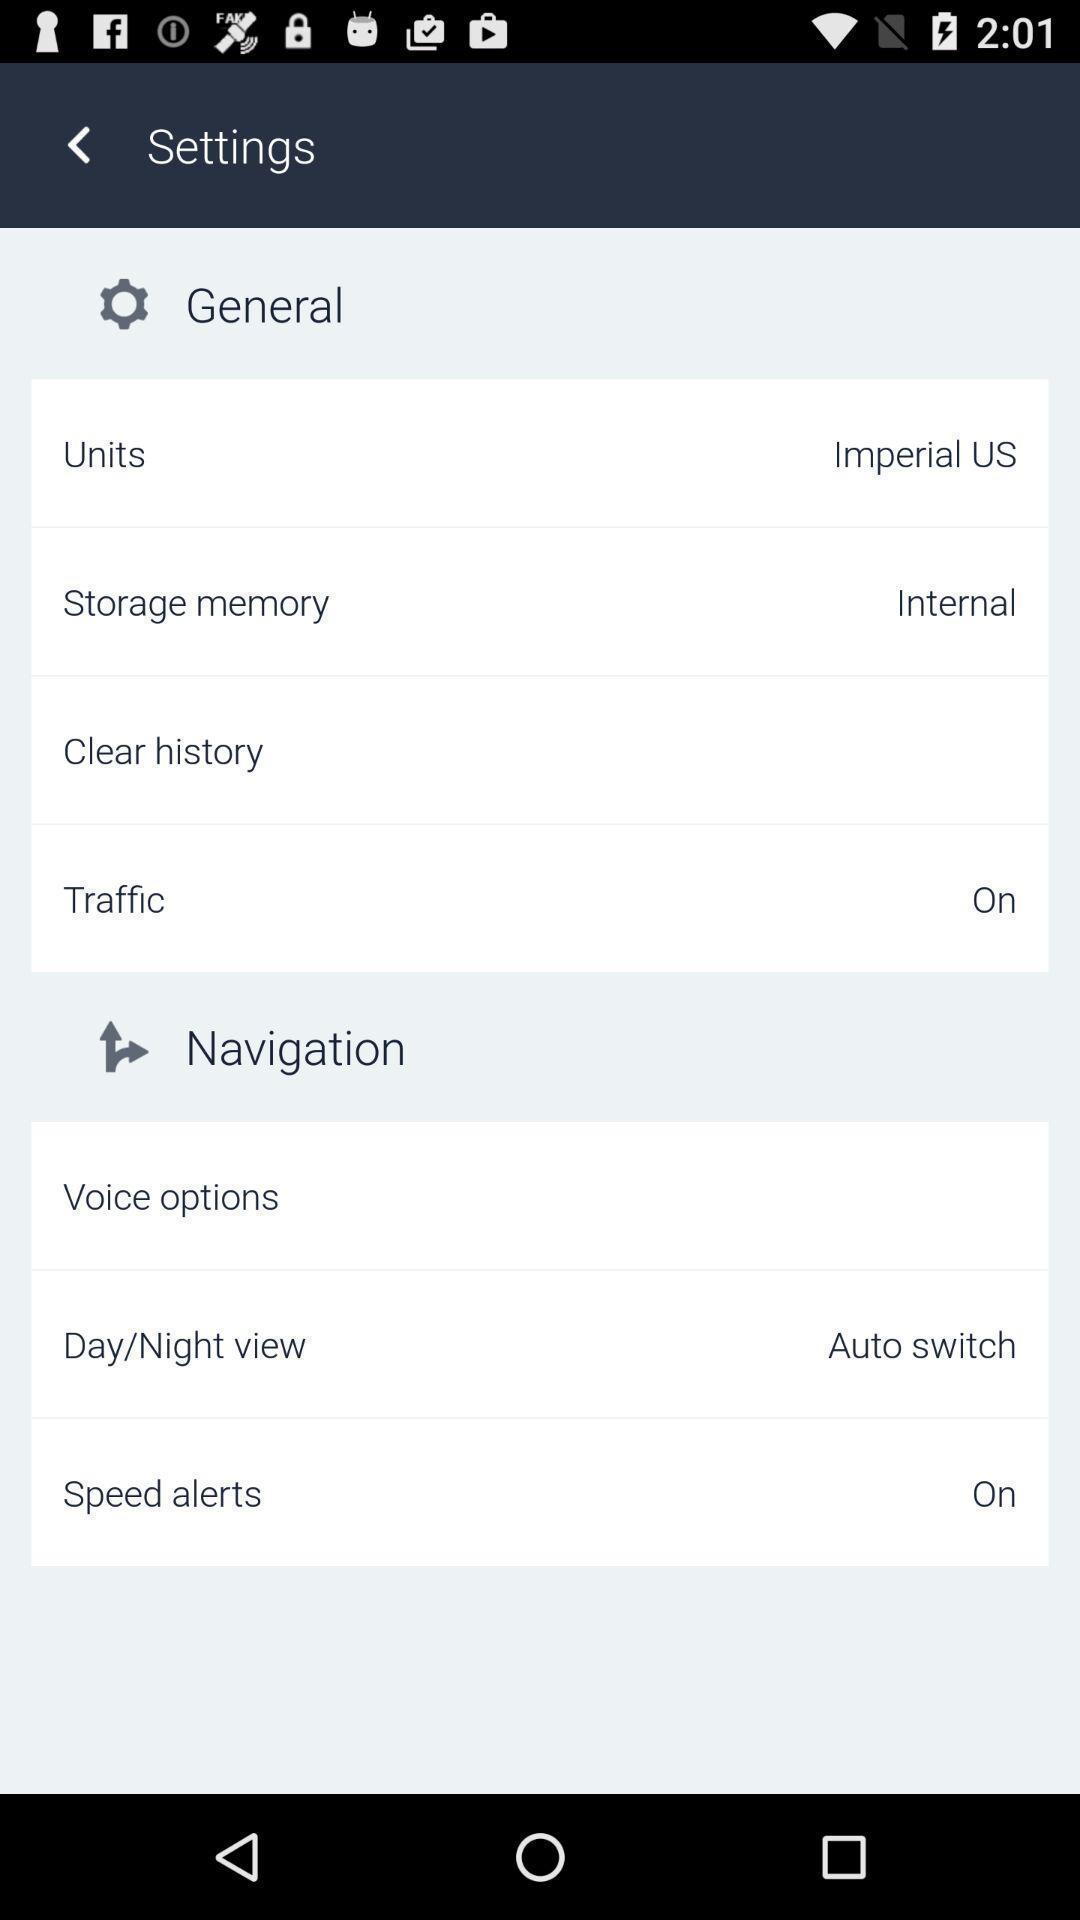What can you discern from this picture? Settings page with various options. 